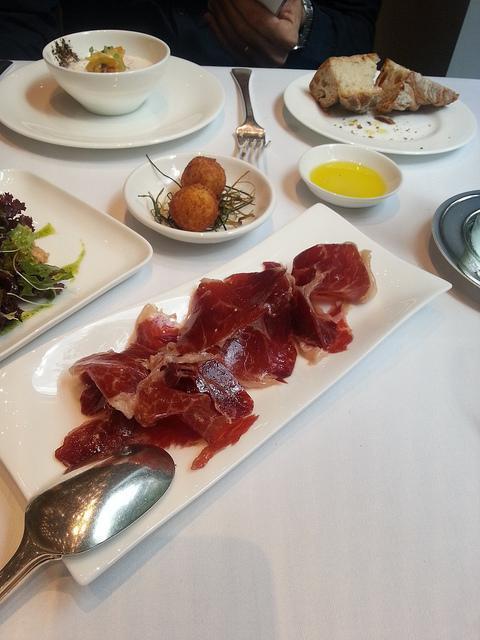How many spoons are on the table?
Give a very brief answer. 1. How many bowls can you see?
Give a very brief answer. 3. How many donuts have a pumpkin face?
Give a very brief answer. 0. 